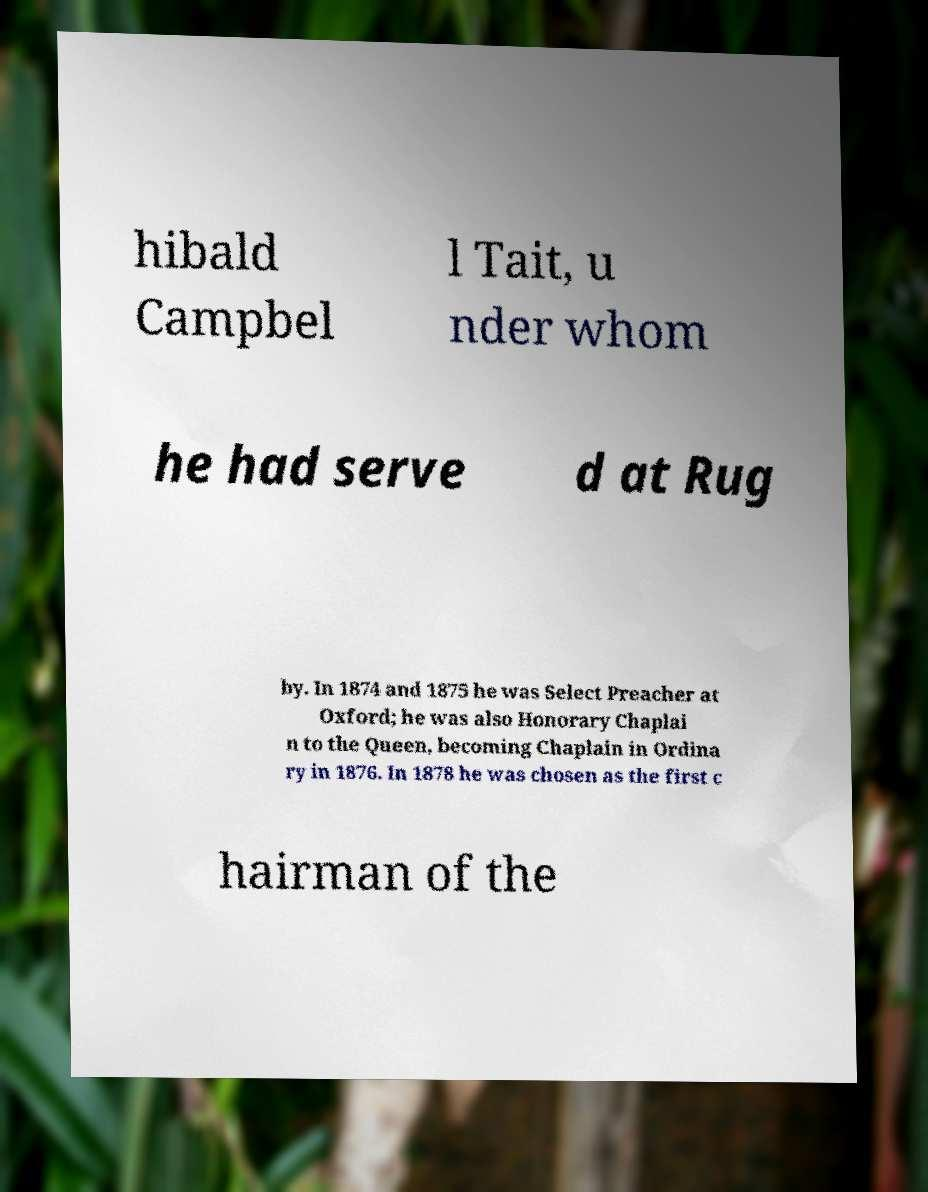Can you read and provide the text displayed in the image?This photo seems to have some interesting text. Can you extract and type it out for me? hibald Campbel l Tait, u nder whom he had serve d at Rug by. In 1874 and 1875 he was Select Preacher at Oxford; he was also Honorary Chaplai n to the Queen, becoming Chaplain in Ordina ry in 1876. In 1878 he was chosen as the first c hairman of the 